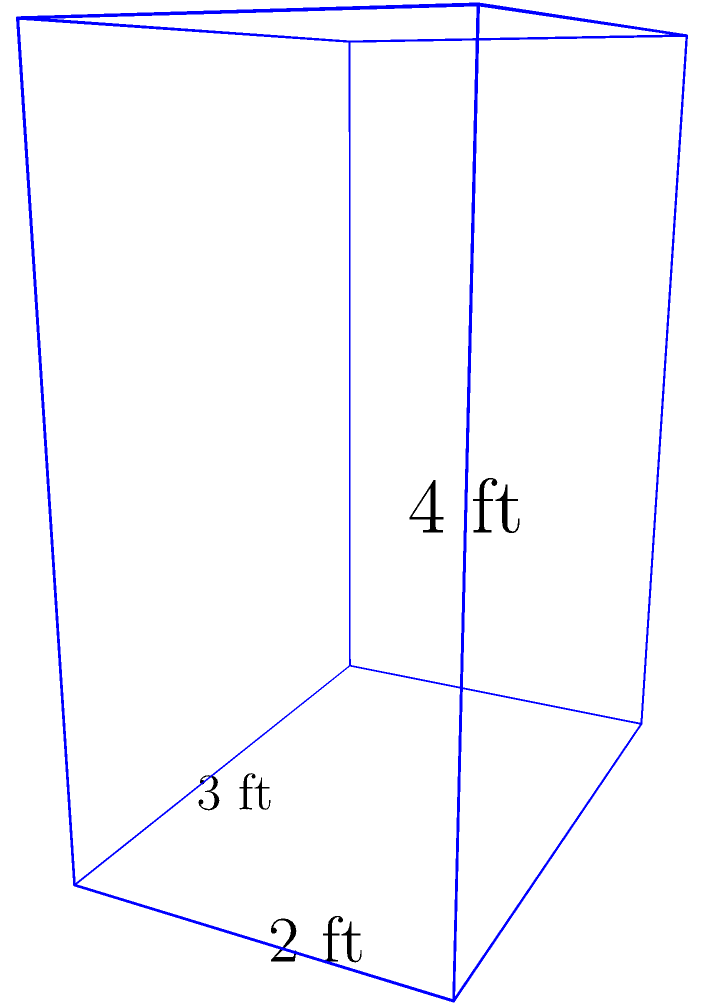You're organizing a new filing system and need to calculate the surface area of a rectangular box-shaped filing cabinet. The cabinet measures 3 feet in length, 2 feet in width, and 4 feet in height. What is the total surface area of the cabinet in square feet? To find the surface area of a rectangular box, we need to calculate the area of each face and sum them up. Let's break it down step-by-step:

1. Identify the dimensions:
   Length (l) = 3 feet
   Width (w) = 2 feet
   Height (h) = 4 feet

2. Calculate the area of each face:
   - Front and back faces (2): $2 * (l * h) = 2 * (3 * 4) = 24$ sq ft
   - Left and right faces (2): $2 * (w * h) = 2 * (2 * 4) = 16$ sq ft
   - Top and bottom faces (2): $2 * (l * w) = 2 * (3 * 2) = 12$ sq ft

3. Sum up all the face areas:
   Total surface area = Front/back + Left/right + Top/bottom
   $= 24 + 16 + 12 = 52$ sq ft

Therefore, the total surface area of the filing cabinet is 52 square feet.
Answer: 52 sq ft 